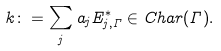Convert formula to latex. <formula><loc_0><loc_0><loc_500><loc_500>k \colon = \sum _ { j } a _ { j } E ^ { * } _ { j , \Gamma } \in C h a r ( \Gamma ) .</formula> 